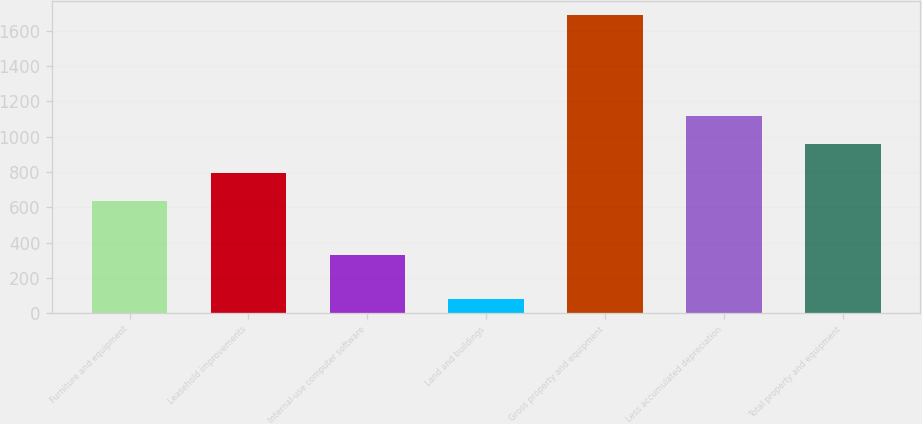Convert chart to OTSL. <chart><loc_0><loc_0><loc_500><loc_500><bar_chart><fcel>Furniture and equipment<fcel>Leasehold improvements<fcel>Internal-use computer software<fcel>Land and buildings<fcel>Gross property and equipment<fcel>Less accumulated depreciation<fcel>Total property and equipment<nl><fcel>634.8<fcel>795.56<fcel>331.3<fcel>79<fcel>1686.6<fcel>1117.08<fcel>956.32<nl></chart> 